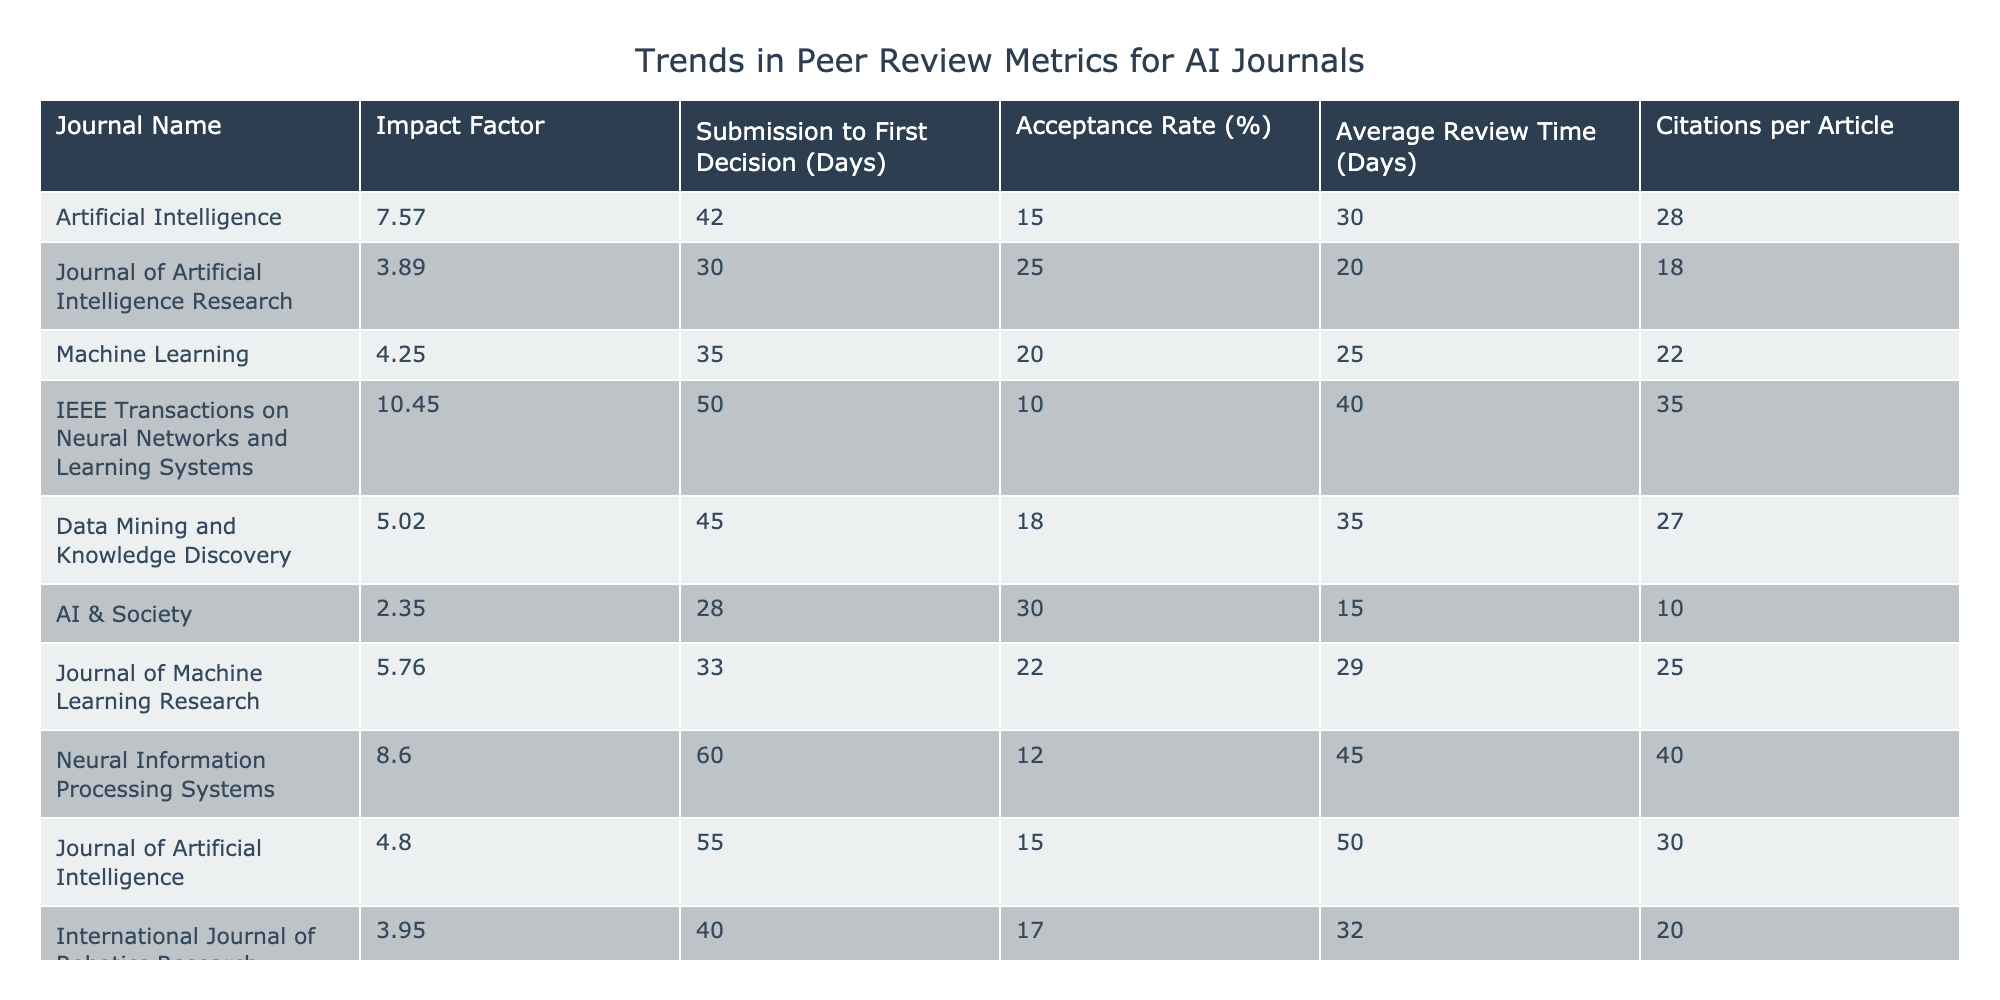What is the Impact Factor of the Journal of Artificial Intelligence Research? The Impact Factor for the Journal of Artificial Intelligence Research is directly listed in the table as 3.89.
Answer: 3.89 What is the average acceptance rate of all the journals listed? The acceptance rates provided are 15, 25, 20, 10, 18, 30, 22, 12, 15, and 17. Summing these gives 15 + 25 + 20 + 10 + 18 + 30 + 22 + 12 + 15 + 17 =  179. There are 10 journals, so the average is 179/10 = 17.9.
Answer: 17.9 Which journal has the longest submission to first decision time? By comparing the 'Submission to First Decision (Days)' column, the journal with the longest time is Neural Information Processing Systems with 60 days.
Answer: Neural Information Processing Systems True or False: The Journal of Machine Learning Research has a longer average review time than the IEEE Transactions on Neural Networks and Learning Systems. The average review time for the Journal of Machine Learning Research is 29 days while that for the IEEE Transactions on Neural Networks and Learning Systems is 40 days. Since 29 is less than 40, the statement is false.
Answer: False What is the difference in citations per article between the journal with the highest Impact Factor and the journal with the lowest Impact Factor? The journal with the highest Impact Factor is IEEE Transactions on Neural Networks and Learning Systems (10.45) and the lowest is AI & Society (2.35). The difference in citations per article is 35 (IEEE) - 10 (AI & Society) = 25.
Answer: 25 Which journal has the highest acceptance rate and what is the value? From the acceptance rates listed, AI & Society has the highest acceptance rate at 30%.
Answer: AI & Society, 30% What is the average review time across all journals, and how does it compare to the average submission to first decision time? The average review times are 30, 20, 25, 40, 35, 15, 29, 45, 50, and 32, summing these gives 30 + 20 + 25 + 40 + 35 + 15 + 29 + 45 + 50 + 32 =  350. The average review time is 350/10 = 35 days. The average submission to first decision time is (42 + 30 + 35 + 50 + 45 + 28 + 33 + 60 + 55 + 40) / 10 = 42.8 days. 35 is less than 42.8.
Answer: Review time average is 35, which is less than submission time average 42.8 